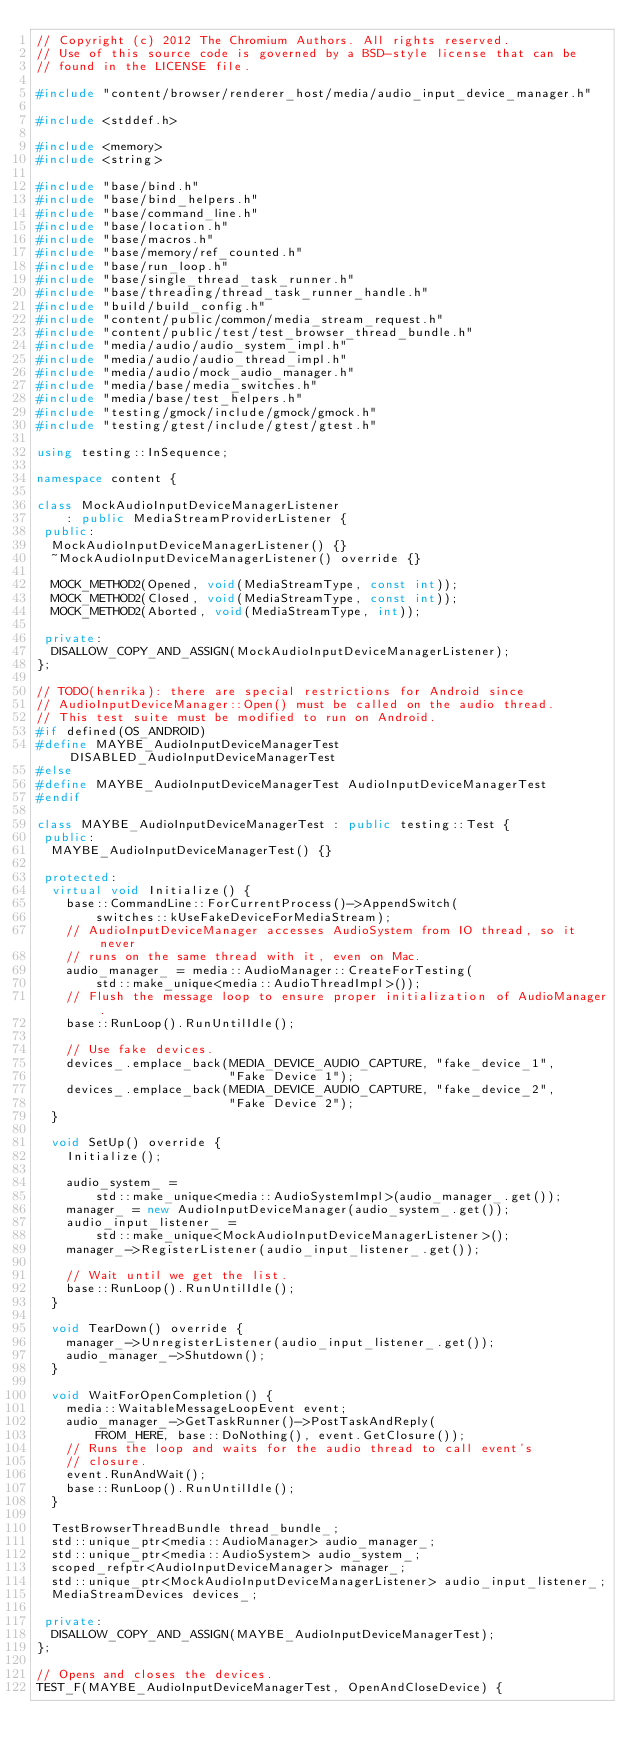Convert code to text. <code><loc_0><loc_0><loc_500><loc_500><_C++_>// Copyright (c) 2012 The Chromium Authors. All rights reserved.
// Use of this source code is governed by a BSD-style license that can be
// found in the LICENSE file.

#include "content/browser/renderer_host/media/audio_input_device_manager.h"

#include <stddef.h>

#include <memory>
#include <string>

#include "base/bind.h"
#include "base/bind_helpers.h"
#include "base/command_line.h"
#include "base/location.h"
#include "base/macros.h"
#include "base/memory/ref_counted.h"
#include "base/run_loop.h"
#include "base/single_thread_task_runner.h"
#include "base/threading/thread_task_runner_handle.h"
#include "build/build_config.h"
#include "content/public/common/media_stream_request.h"
#include "content/public/test/test_browser_thread_bundle.h"
#include "media/audio/audio_system_impl.h"
#include "media/audio/audio_thread_impl.h"
#include "media/audio/mock_audio_manager.h"
#include "media/base/media_switches.h"
#include "media/base/test_helpers.h"
#include "testing/gmock/include/gmock/gmock.h"
#include "testing/gtest/include/gtest/gtest.h"

using testing::InSequence;

namespace content {

class MockAudioInputDeviceManagerListener
    : public MediaStreamProviderListener {
 public:
  MockAudioInputDeviceManagerListener() {}
  ~MockAudioInputDeviceManagerListener() override {}

  MOCK_METHOD2(Opened, void(MediaStreamType, const int));
  MOCK_METHOD2(Closed, void(MediaStreamType, const int));
  MOCK_METHOD2(Aborted, void(MediaStreamType, int));

 private:
  DISALLOW_COPY_AND_ASSIGN(MockAudioInputDeviceManagerListener);
};

// TODO(henrika): there are special restrictions for Android since
// AudioInputDeviceManager::Open() must be called on the audio thread.
// This test suite must be modified to run on Android.
#if defined(OS_ANDROID)
#define MAYBE_AudioInputDeviceManagerTest DISABLED_AudioInputDeviceManagerTest
#else
#define MAYBE_AudioInputDeviceManagerTest AudioInputDeviceManagerTest
#endif

class MAYBE_AudioInputDeviceManagerTest : public testing::Test {
 public:
  MAYBE_AudioInputDeviceManagerTest() {}

 protected:
  virtual void Initialize() {
    base::CommandLine::ForCurrentProcess()->AppendSwitch(
        switches::kUseFakeDeviceForMediaStream);
    // AudioInputDeviceManager accesses AudioSystem from IO thread, so it never
    // runs on the same thread with it, even on Mac.
    audio_manager_ = media::AudioManager::CreateForTesting(
        std::make_unique<media::AudioThreadImpl>());
    // Flush the message loop to ensure proper initialization of AudioManager.
    base::RunLoop().RunUntilIdle();

    // Use fake devices.
    devices_.emplace_back(MEDIA_DEVICE_AUDIO_CAPTURE, "fake_device_1",
                          "Fake Device 1");
    devices_.emplace_back(MEDIA_DEVICE_AUDIO_CAPTURE, "fake_device_2",
                          "Fake Device 2");
  }

  void SetUp() override {
    Initialize();

    audio_system_ =
        std::make_unique<media::AudioSystemImpl>(audio_manager_.get());
    manager_ = new AudioInputDeviceManager(audio_system_.get());
    audio_input_listener_ =
        std::make_unique<MockAudioInputDeviceManagerListener>();
    manager_->RegisterListener(audio_input_listener_.get());

    // Wait until we get the list.
    base::RunLoop().RunUntilIdle();
  }

  void TearDown() override {
    manager_->UnregisterListener(audio_input_listener_.get());
    audio_manager_->Shutdown();
  }

  void WaitForOpenCompletion() {
    media::WaitableMessageLoopEvent event;
    audio_manager_->GetTaskRunner()->PostTaskAndReply(
        FROM_HERE, base::DoNothing(), event.GetClosure());
    // Runs the loop and waits for the audio thread to call event's
    // closure.
    event.RunAndWait();
    base::RunLoop().RunUntilIdle();
  }

  TestBrowserThreadBundle thread_bundle_;
  std::unique_ptr<media::AudioManager> audio_manager_;
  std::unique_ptr<media::AudioSystem> audio_system_;
  scoped_refptr<AudioInputDeviceManager> manager_;
  std::unique_ptr<MockAudioInputDeviceManagerListener> audio_input_listener_;
  MediaStreamDevices devices_;

 private:
  DISALLOW_COPY_AND_ASSIGN(MAYBE_AudioInputDeviceManagerTest);
};

// Opens and closes the devices.
TEST_F(MAYBE_AudioInputDeviceManagerTest, OpenAndCloseDevice) {</code> 